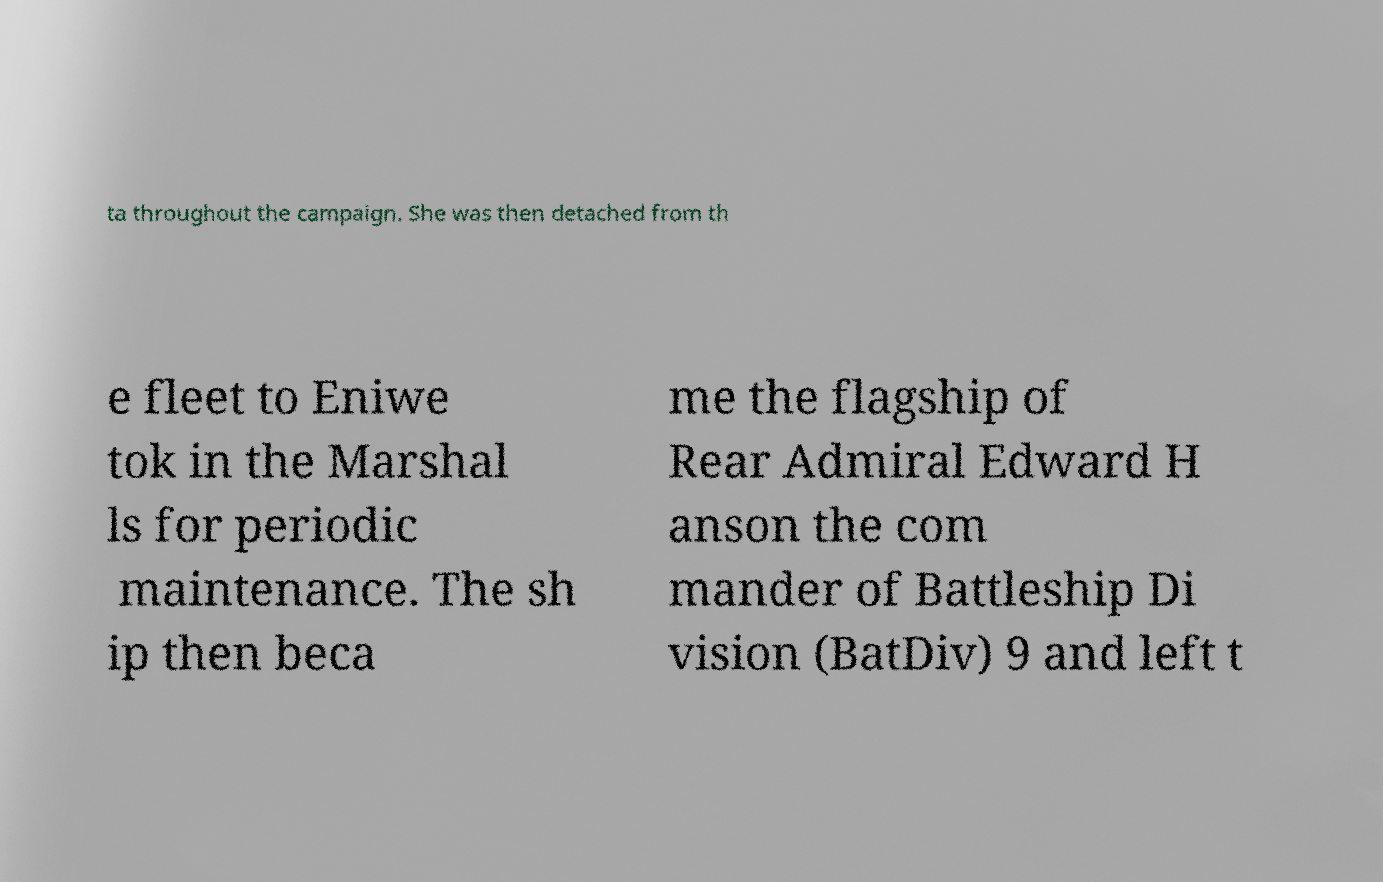Could you extract and type out the text from this image? ta throughout the campaign. She was then detached from th e fleet to Eniwe tok in the Marshal ls for periodic maintenance. The sh ip then beca me the flagship of Rear Admiral Edward H anson the com mander of Battleship Di vision (BatDiv) 9 and left t 